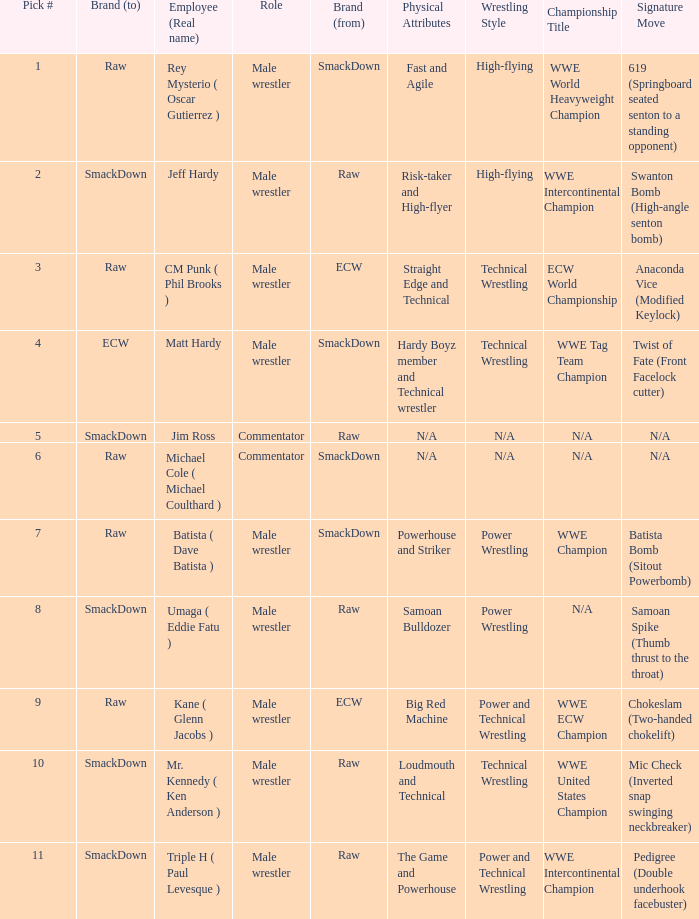What role did Pick # 10 have? Male wrestler. 